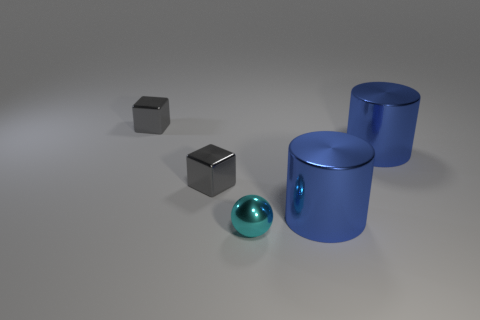Is there anything else that has the same shape as the small cyan metallic object?
Provide a succinct answer. No. Are there an equal number of objects that are in front of the cyan ball and tiny gray shiny cubes?
Make the answer very short. No. Are there any other large things of the same shape as the cyan metal object?
Provide a short and direct response. No. How many objects are either gray blocks or small balls?
Your answer should be very brief. 3. Are there more blue cylinders in front of the cyan object than small cyan spheres?
Provide a succinct answer. No. What number of things are either tiny things that are behind the cyan shiny sphere or tiny metal objects on the left side of the tiny metal sphere?
Give a very brief answer. 2. How many cubes are the same color as the shiny sphere?
Offer a very short reply. 0. How many things are tiny objects that are on the left side of the cyan metallic object or big blue objects?
Keep it short and to the point. 4. What number of small gray cubes are made of the same material as the small cyan thing?
Your answer should be compact. 2. What number of metal things are behind the ball?
Your answer should be compact. 4. 